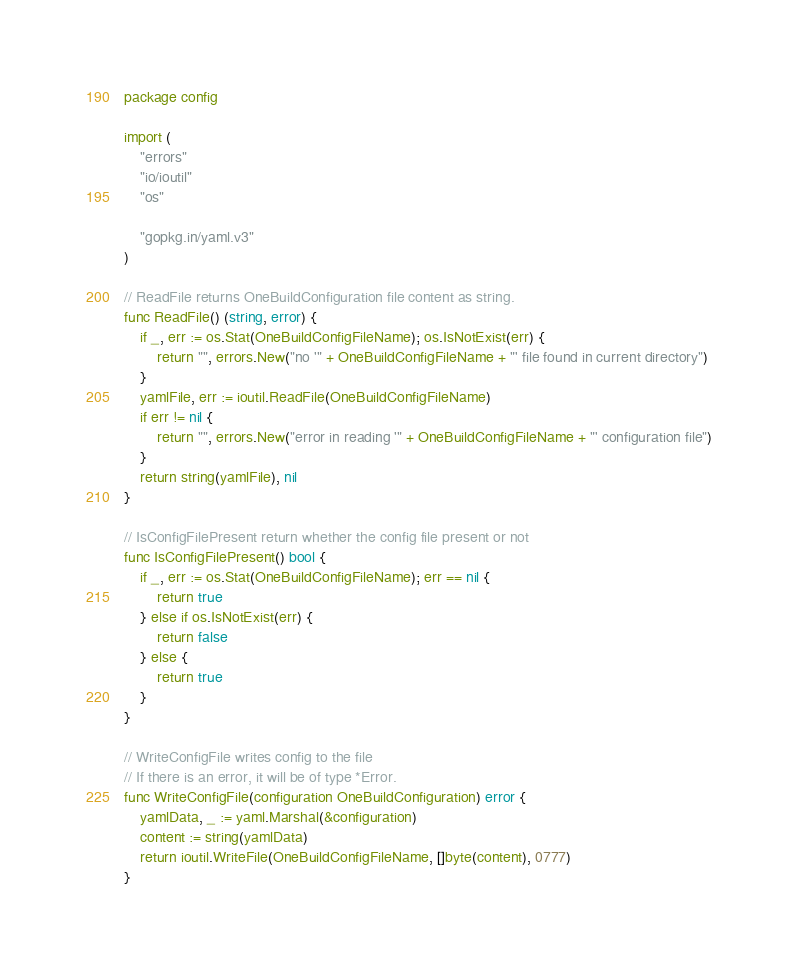<code> <loc_0><loc_0><loc_500><loc_500><_Go_>package config

import (
	"errors"
	"io/ioutil"
	"os"

	"gopkg.in/yaml.v3"
)

// ReadFile returns OneBuildConfiguration file content as string.
func ReadFile() (string, error) {
	if _, err := os.Stat(OneBuildConfigFileName); os.IsNotExist(err) {
		return "", errors.New("no '" + OneBuildConfigFileName + "' file found in current directory")
	}
	yamlFile, err := ioutil.ReadFile(OneBuildConfigFileName)
	if err != nil {
		return "", errors.New("error in reading '" + OneBuildConfigFileName + "' configuration file")
	}
	return string(yamlFile), nil
}

// IsConfigFilePresent return whether the config file present or not
func IsConfigFilePresent() bool {
	if _, err := os.Stat(OneBuildConfigFileName); err == nil {
		return true
	} else if os.IsNotExist(err) {
		return false
	} else {
		return true
	}
}

// WriteConfigFile writes config to the file
// If there is an error, it will be of type *Error.
func WriteConfigFile(configuration OneBuildConfiguration) error {
	yamlData, _ := yaml.Marshal(&configuration)
	content := string(yamlData)
	return ioutil.WriteFile(OneBuildConfigFileName, []byte(content), 0777)
}
</code> 